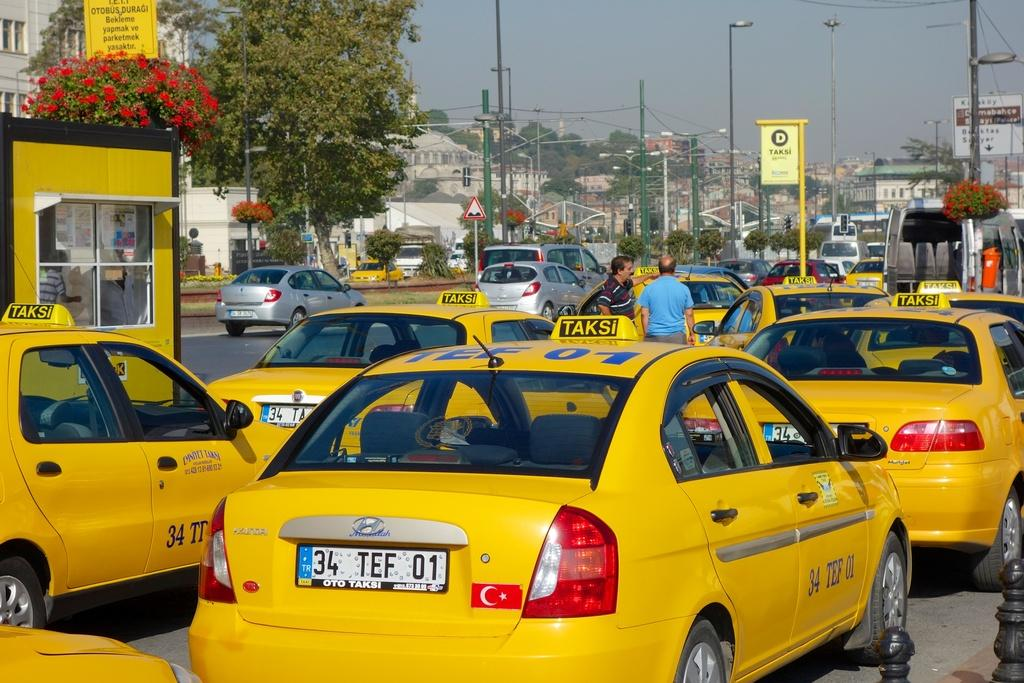Provide a one-sentence caption for the provided image. A yellow taxi with the license plate 34 TEF 01 waiting in traffic. 